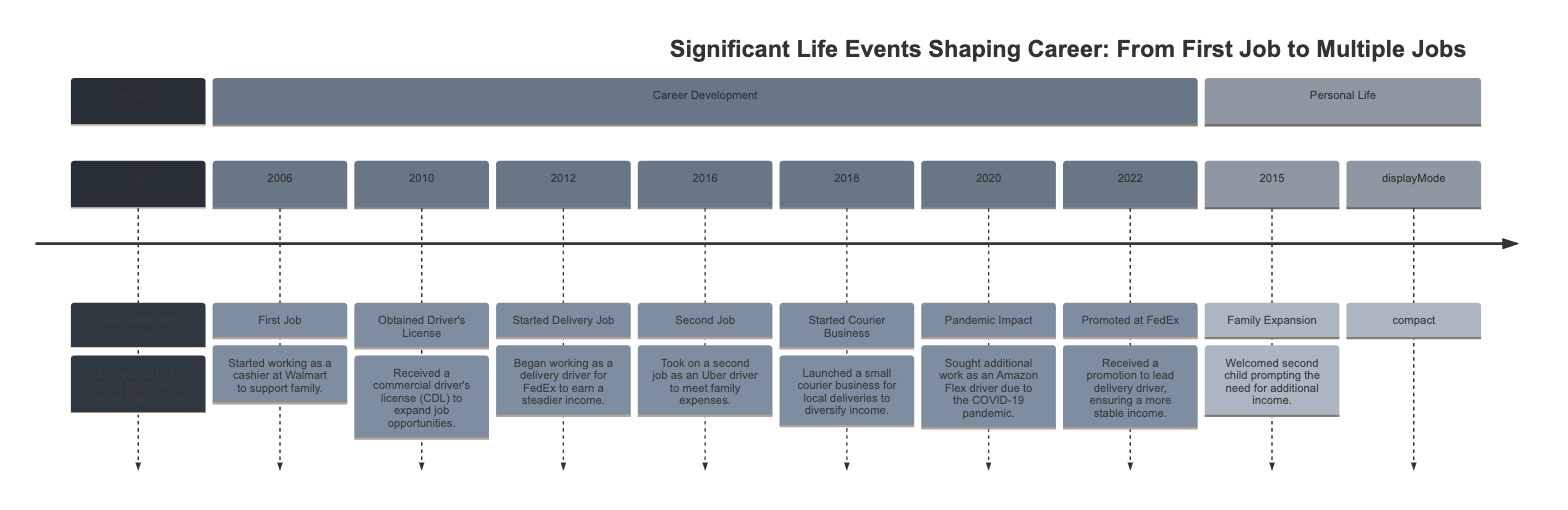What year did you graduate high school? The timeline indicates that the event "Graduated High School" occurred in the year 2005. It is explicitly stated next to the event in the diagram.
Answer: 2005 What was your first job? According to the timeline, the first job listed is as a cashier at Walmart, which is described alongside the year 2006.
Answer: Cashier at Walmart How many jobs were held by 2018? By 2018, multiple jobs are indicated: the delivery job at FedEx, a second job as an Uber driver, and a newly started courier business. There are three jobs accounted for.
Answer: Three What significant life event occurred in 2015? The timeline shows "Family Expansion" in 2015, which corresponds to the event where a second child was welcomed. This information is found directly under the year 2015 in the diagram.
Answer: Family Expansion Which job was taken on in 2016? The event labeled "Second Job" identifies the role taken in 2016. This describes taking on a job as an Uber driver, as specified in the diagram.
Answer: Uber driver How did the pandemic impact job opportunities in 2020? The diagram states that in 2020, there was a "Pandemic Impact" event, prompting the search for additional work. This specifically refers to becoming an Amazon Flex driver due to the COVID-19 pandemic.
Answer: Amazon Flex driver Which year did you receive a promotion at FedEx? The timeline notes a promotion at FedEx occurred in 2022, detailed in the event "Promoted at FedEx." This can be directly found under that year in the diagram.
Answer: 2022 How did your career path change between 2012 and 2016? Between 2012 and 2016, several transitions occurred: starting as a delivery driver in 2012, then taking on an Uber driver job in 2016 to manage family expenses. This indicates an expansion of job roles within that timeframe.
Answer: Expanded job roles What was the first major step taken to increase income? The first major step to increase income appears to be starting as a delivery driver in 2012, following the earlier positions in retail and obtaining a driver's license. This can be determined by tracing back from the delivery job to earlier events.
Answer: Started Delivery Job 